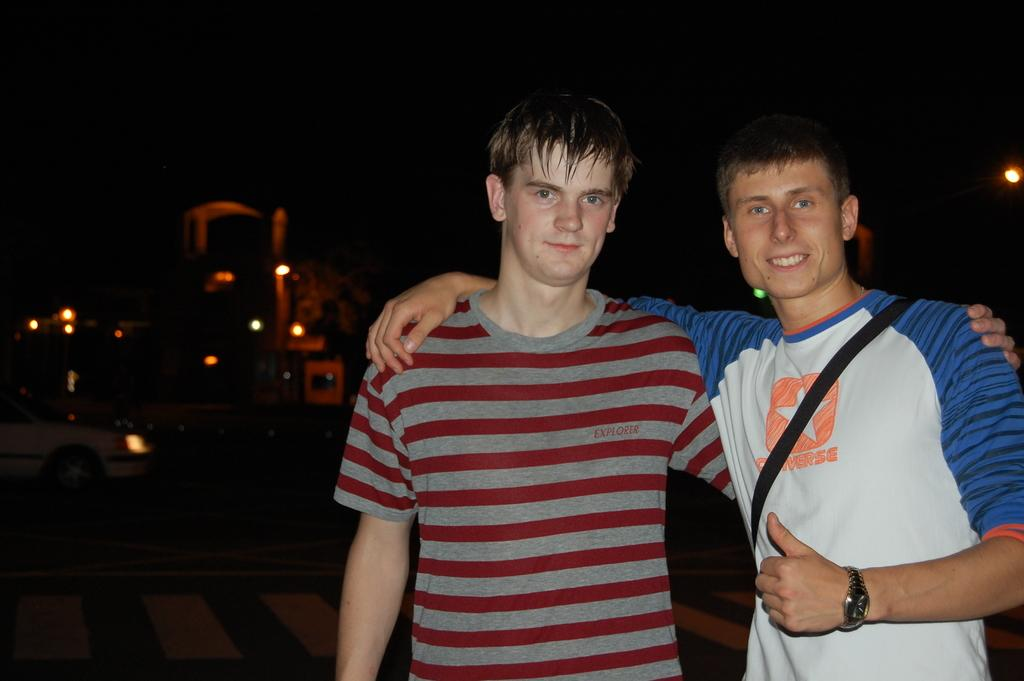<image>
Create a compact narrative representing the image presented. A young man wearing a Converse shirt has his arm around his friend. 